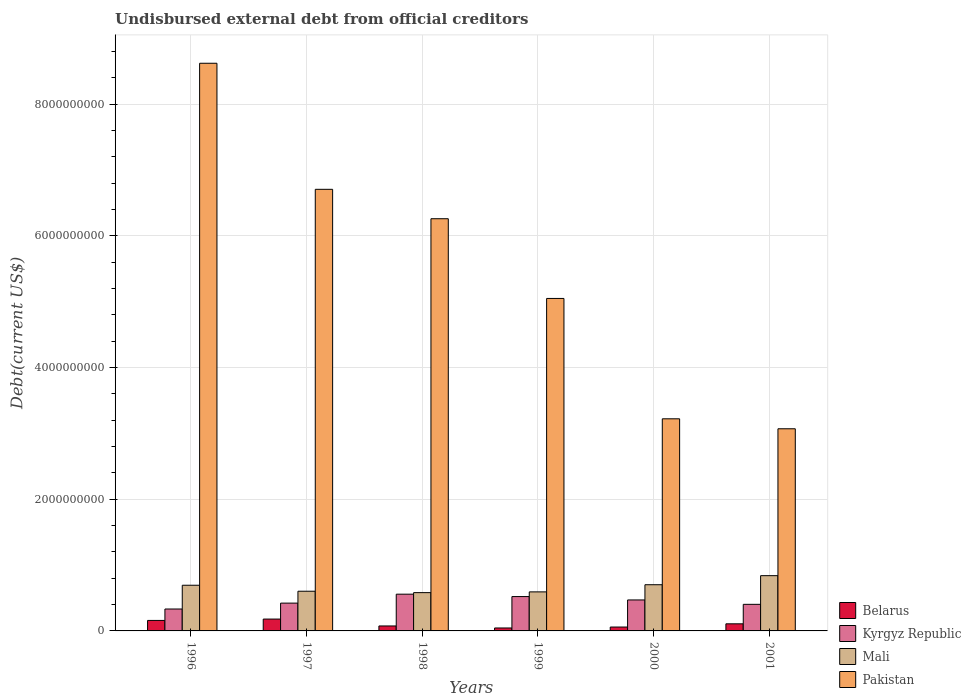How many different coloured bars are there?
Ensure brevity in your answer.  4. How many groups of bars are there?
Offer a terse response. 6. Are the number of bars on each tick of the X-axis equal?
Offer a very short reply. Yes. What is the total debt in Mali in 1996?
Make the answer very short. 6.94e+08. Across all years, what is the maximum total debt in Kyrgyz Republic?
Give a very brief answer. 5.58e+08. Across all years, what is the minimum total debt in Mali?
Your response must be concise. 5.82e+08. In which year was the total debt in Kyrgyz Republic maximum?
Give a very brief answer. 1998. In which year was the total debt in Pakistan minimum?
Offer a very short reply. 2001. What is the total total debt in Belarus in the graph?
Give a very brief answer. 6.27e+08. What is the difference between the total debt in Kyrgyz Republic in 1996 and that in 1999?
Keep it short and to the point. -1.89e+08. What is the difference between the total debt in Kyrgyz Republic in 2000 and the total debt in Mali in 1997?
Provide a succinct answer. -1.33e+08. What is the average total debt in Belarus per year?
Offer a terse response. 1.04e+08. In the year 1996, what is the difference between the total debt in Pakistan and total debt in Belarus?
Your answer should be compact. 8.46e+09. What is the ratio of the total debt in Belarus in 1998 to that in 2000?
Provide a short and direct response. 1.28. Is the difference between the total debt in Pakistan in 1999 and 2001 greater than the difference between the total debt in Belarus in 1999 and 2001?
Your response must be concise. Yes. What is the difference between the highest and the second highest total debt in Kyrgyz Republic?
Give a very brief answer. 3.62e+07. What is the difference between the highest and the lowest total debt in Pakistan?
Your response must be concise. 5.55e+09. Is the sum of the total debt in Belarus in 1997 and 2001 greater than the maximum total debt in Mali across all years?
Keep it short and to the point. No. Is it the case that in every year, the sum of the total debt in Mali and total debt in Belarus is greater than the sum of total debt in Pakistan and total debt in Kyrgyz Republic?
Your response must be concise. Yes. What does the 1st bar from the left in 2000 represents?
Keep it short and to the point. Belarus. What does the 3rd bar from the right in 2001 represents?
Your answer should be compact. Kyrgyz Republic. Are all the bars in the graph horizontal?
Your response must be concise. No. How many years are there in the graph?
Keep it short and to the point. 6. What is the difference between two consecutive major ticks on the Y-axis?
Keep it short and to the point. 2.00e+09. Does the graph contain grids?
Your answer should be very brief. Yes. Where does the legend appear in the graph?
Provide a short and direct response. Bottom right. How many legend labels are there?
Offer a terse response. 4. How are the legend labels stacked?
Provide a succinct answer. Vertical. What is the title of the graph?
Your answer should be very brief. Undisbursed external debt from official creditors. What is the label or title of the Y-axis?
Give a very brief answer. Debt(current US$). What is the Debt(current US$) of Belarus in 1996?
Your answer should be compact. 1.59e+08. What is the Debt(current US$) in Kyrgyz Republic in 1996?
Provide a succinct answer. 3.33e+08. What is the Debt(current US$) of Mali in 1996?
Your response must be concise. 6.94e+08. What is the Debt(current US$) of Pakistan in 1996?
Give a very brief answer. 8.62e+09. What is the Debt(current US$) in Belarus in 1997?
Provide a short and direct response. 1.80e+08. What is the Debt(current US$) of Kyrgyz Republic in 1997?
Keep it short and to the point. 4.22e+08. What is the Debt(current US$) in Mali in 1997?
Offer a very short reply. 6.03e+08. What is the Debt(current US$) in Pakistan in 1997?
Make the answer very short. 6.71e+09. What is the Debt(current US$) in Belarus in 1998?
Provide a succinct answer. 7.55e+07. What is the Debt(current US$) of Kyrgyz Republic in 1998?
Your response must be concise. 5.58e+08. What is the Debt(current US$) of Mali in 1998?
Provide a short and direct response. 5.82e+08. What is the Debt(current US$) in Pakistan in 1998?
Provide a short and direct response. 6.26e+09. What is the Debt(current US$) of Belarus in 1999?
Provide a succinct answer. 4.48e+07. What is the Debt(current US$) of Kyrgyz Republic in 1999?
Give a very brief answer. 5.22e+08. What is the Debt(current US$) of Mali in 1999?
Your response must be concise. 5.93e+08. What is the Debt(current US$) in Pakistan in 1999?
Offer a very short reply. 5.05e+09. What is the Debt(current US$) of Belarus in 2000?
Keep it short and to the point. 5.90e+07. What is the Debt(current US$) of Kyrgyz Republic in 2000?
Keep it short and to the point. 4.70e+08. What is the Debt(current US$) in Mali in 2000?
Offer a very short reply. 7.02e+08. What is the Debt(current US$) of Pakistan in 2000?
Your answer should be compact. 3.22e+09. What is the Debt(current US$) of Belarus in 2001?
Your response must be concise. 1.08e+08. What is the Debt(current US$) in Kyrgyz Republic in 2001?
Provide a succinct answer. 4.04e+08. What is the Debt(current US$) in Mali in 2001?
Offer a terse response. 8.39e+08. What is the Debt(current US$) in Pakistan in 2001?
Give a very brief answer. 3.07e+09. Across all years, what is the maximum Debt(current US$) in Belarus?
Make the answer very short. 1.80e+08. Across all years, what is the maximum Debt(current US$) in Kyrgyz Republic?
Your answer should be very brief. 5.58e+08. Across all years, what is the maximum Debt(current US$) in Mali?
Provide a short and direct response. 8.39e+08. Across all years, what is the maximum Debt(current US$) of Pakistan?
Keep it short and to the point. 8.62e+09. Across all years, what is the minimum Debt(current US$) of Belarus?
Your answer should be very brief. 4.48e+07. Across all years, what is the minimum Debt(current US$) of Kyrgyz Republic?
Offer a terse response. 3.33e+08. Across all years, what is the minimum Debt(current US$) of Mali?
Keep it short and to the point. 5.82e+08. Across all years, what is the minimum Debt(current US$) in Pakistan?
Give a very brief answer. 3.07e+09. What is the total Debt(current US$) of Belarus in the graph?
Provide a short and direct response. 6.27e+08. What is the total Debt(current US$) of Kyrgyz Republic in the graph?
Provide a succinct answer. 2.71e+09. What is the total Debt(current US$) in Mali in the graph?
Provide a succinct answer. 4.01e+09. What is the total Debt(current US$) in Pakistan in the graph?
Your answer should be very brief. 3.29e+1. What is the difference between the Debt(current US$) of Belarus in 1996 and that in 1997?
Offer a terse response. -2.06e+07. What is the difference between the Debt(current US$) of Kyrgyz Republic in 1996 and that in 1997?
Provide a succinct answer. -8.95e+07. What is the difference between the Debt(current US$) in Mali in 1996 and that in 1997?
Ensure brevity in your answer.  9.09e+07. What is the difference between the Debt(current US$) of Pakistan in 1996 and that in 1997?
Your response must be concise. 1.91e+09. What is the difference between the Debt(current US$) in Belarus in 1996 and that in 1998?
Ensure brevity in your answer.  8.40e+07. What is the difference between the Debt(current US$) in Kyrgyz Republic in 1996 and that in 1998?
Your answer should be compact. -2.25e+08. What is the difference between the Debt(current US$) of Mali in 1996 and that in 1998?
Give a very brief answer. 1.12e+08. What is the difference between the Debt(current US$) of Pakistan in 1996 and that in 1998?
Give a very brief answer. 2.36e+09. What is the difference between the Debt(current US$) in Belarus in 1996 and that in 1999?
Offer a very short reply. 1.15e+08. What is the difference between the Debt(current US$) of Kyrgyz Republic in 1996 and that in 1999?
Give a very brief answer. -1.89e+08. What is the difference between the Debt(current US$) of Mali in 1996 and that in 1999?
Offer a terse response. 1.01e+08. What is the difference between the Debt(current US$) in Pakistan in 1996 and that in 1999?
Ensure brevity in your answer.  3.57e+09. What is the difference between the Debt(current US$) in Belarus in 1996 and that in 2000?
Your answer should be compact. 1.00e+08. What is the difference between the Debt(current US$) in Kyrgyz Republic in 1996 and that in 2000?
Your answer should be compact. -1.38e+08. What is the difference between the Debt(current US$) of Mali in 1996 and that in 2000?
Provide a short and direct response. -7.92e+06. What is the difference between the Debt(current US$) in Pakistan in 1996 and that in 2000?
Provide a succinct answer. 5.40e+09. What is the difference between the Debt(current US$) of Belarus in 1996 and that in 2001?
Keep it short and to the point. 5.16e+07. What is the difference between the Debt(current US$) in Kyrgyz Republic in 1996 and that in 2001?
Provide a succinct answer. -7.09e+07. What is the difference between the Debt(current US$) of Mali in 1996 and that in 2001?
Your answer should be compact. -1.45e+08. What is the difference between the Debt(current US$) in Pakistan in 1996 and that in 2001?
Keep it short and to the point. 5.55e+09. What is the difference between the Debt(current US$) in Belarus in 1997 and that in 1998?
Ensure brevity in your answer.  1.05e+08. What is the difference between the Debt(current US$) in Kyrgyz Republic in 1997 and that in 1998?
Your answer should be very brief. -1.36e+08. What is the difference between the Debt(current US$) in Mali in 1997 and that in 1998?
Your answer should be compact. 2.14e+07. What is the difference between the Debt(current US$) in Pakistan in 1997 and that in 1998?
Give a very brief answer. 4.47e+08. What is the difference between the Debt(current US$) of Belarus in 1997 and that in 1999?
Your response must be concise. 1.35e+08. What is the difference between the Debt(current US$) of Kyrgyz Republic in 1997 and that in 1999?
Give a very brief answer. -9.94e+07. What is the difference between the Debt(current US$) in Mali in 1997 and that in 1999?
Offer a terse response. 1.00e+07. What is the difference between the Debt(current US$) in Pakistan in 1997 and that in 1999?
Provide a short and direct response. 1.66e+09. What is the difference between the Debt(current US$) of Belarus in 1997 and that in 2000?
Make the answer very short. 1.21e+08. What is the difference between the Debt(current US$) in Kyrgyz Republic in 1997 and that in 2000?
Your response must be concise. -4.80e+07. What is the difference between the Debt(current US$) in Mali in 1997 and that in 2000?
Provide a succinct answer. -9.88e+07. What is the difference between the Debt(current US$) in Pakistan in 1997 and that in 2000?
Give a very brief answer. 3.49e+09. What is the difference between the Debt(current US$) of Belarus in 1997 and that in 2001?
Make the answer very short. 7.22e+07. What is the difference between the Debt(current US$) of Kyrgyz Republic in 1997 and that in 2001?
Offer a very short reply. 1.86e+07. What is the difference between the Debt(current US$) in Mali in 1997 and that in 2001?
Keep it short and to the point. -2.36e+08. What is the difference between the Debt(current US$) in Pakistan in 1997 and that in 2001?
Make the answer very short. 3.64e+09. What is the difference between the Debt(current US$) of Belarus in 1998 and that in 1999?
Keep it short and to the point. 3.07e+07. What is the difference between the Debt(current US$) in Kyrgyz Republic in 1998 and that in 1999?
Make the answer very short. 3.62e+07. What is the difference between the Debt(current US$) in Mali in 1998 and that in 1999?
Your answer should be compact. -1.13e+07. What is the difference between the Debt(current US$) of Pakistan in 1998 and that in 1999?
Offer a terse response. 1.21e+09. What is the difference between the Debt(current US$) in Belarus in 1998 and that in 2000?
Your answer should be very brief. 1.64e+07. What is the difference between the Debt(current US$) of Kyrgyz Republic in 1998 and that in 2000?
Offer a very short reply. 8.76e+07. What is the difference between the Debt(current US$) of Mali in 1998 and that in 2000?
Offer a very short reply. -1.20e+08. What is the difference between the Debt(current US$) in Pakistan in 1998 and that in 2000?
Provide a short and direct response. 3.04e+09. What is the difference between the Debt(current US$) of Belarus in 1998 and that in 2001?
Keep it short and to the point. -3.24e+07. What is the difference between the Debt(current US$) in Kyrgyz Republic in 1998 and that in 2001?
Offer a terse response. 1.54e+08. What is the difference between the Debt(current US$) of Mali in 1998 and that in 2001?
Your response must be concise. -2.58e+08. What is the difference between the Debt(current US$) in Pakistan in 1998 and that in 2001?
Your answer should be compact. 3.19e+09. What is the difference between the Debt(current US$) in Belarus in 1999 and that in 2000?
Ensure brevity in your answer.  -1.43e+07. What is the difference between the Debt(current US$) in Kyrgyz Republic in 1999 and that in 2000?
Give a very brief answer. 5.14e+07. What is the difference between the Debt(current US$) of Mali in 1999 and that in 2000?
Provide a short and direct response. -1.09e+08. What is the difference between the Debt(current US$) of Pakistan in 1999 and that in 2000?
Ensure brevity in your answer.  1.83e+09. What is the difference between the Debt(current US$) in Belarus in 1999 and that in 2001?
Make the answer very short. -6.31e+07. What is the difference between the Debt(current US$) of Kyrgyz Republic in 1999 and that in 2001?
Your answer should be compact. 1.18e+08. What is the difference between the Debt(current US$) in Mali in 1999 and that in 2001?
Your answer should be very brief. -2.46e+08. What is the difference between the Debt(current US$) of Pakistan in 1999 and that in 2001?
Ensure brevity in your answer.  1.98e+09. What is the difference between the Debt(current US$) of Belarus in 2000 and that in 2001?
Provide a succinct answer. -4.88e+07. What is the difference between the Debt(current US$) in Kyrgyz Republic in 2000 and that in 2001?
Provide a short and direct response. 6.66e+07. What is the difference between the Debt(current US$) in Mali in 2000 and that in 2001?
Keep it short and to the point. -1.38e+08. What is the difference between the Debt(current US$) of Pakistan in 2000 and that in 2001?
Your answer should be very brief. 1.51e+08. What is the difference between the Debt(current US$) of Belarus in 1996 and the Debt(current US$) of Kyrgyz Republic in 1997?
Provide a succinct answer. -2.63e+08. What is the difference between the Debt(current US$) of Belarus in 1996 and the Debt(current US$) of Mali in 1997?
Provide a succinct answer. -4.44e+08. What is the difference between the Debt(current US$) of Belarus in 1996 and the Debt(current US$) of Pakistan in 1997?
Make the answer very short. -6.55e+09. What is the difference between the Debt(current US$) of Kyrgyz Republic in 1996 and the Debt(current US$) of Mali in 1997?
Keep it short and to the point. -2.70e+08. What is the difference between the Debt(current US$) of Kyrgyz Republic in 1996 and the Debt(current US$) of Pakistan in 1997?
Ensure brevity in your answer.  -6.38e+09. What is the difference between the Debt(current US$) of Mali in 1996 and the Debt(current US$) of Pakistan in 1997?
Offer a terse response. -6.01e+09. What is the difference between the Debt(current US$) of Belarus in 1996 and the Debt(current US$) of Kyrgyz Republic in 1998?
Offer a terse response. -3.99e+08. What is the difference between the Debt(current US$) of Belarus in 1996 and the Debt(current US$) of Mali in 1998?
Provide a short and direct response. -4.22e+08. What is the difference between the Debt(current US$) of Belarus in 1996 and the Debt(current US$) of Pakistan in 1998?
Offer a terse response. -6.10e+09. What is the difference between the Debt(current US$) of Kyrgyz Republic in 1996 and the Debt(current US$) of Mali in 1998?
Your answer should be compact. -2.49e+08. What is the difference between the Debt(current US$) of Kyrgyz Republic in 1996 and the Debt(current US$) of Pakistan in 1998?
Offer a terse response. -5.93e+09. What is the difference between the Debt(current US$) of Mali in 1996 and the Debt(current US$) of Pakistan in 1998?
Keep it short and to the point. -5.57e+09. What is the difference between the Debt(current US$) in Belarus in 1996 and the Debt(current US$) in Kyrgyz Republic in 1999?
Provide a succinct answer. -3.62e+08. What is the difference between the Debt(current US$) in Belarus in 1996 and the Debt(current US$) in Mali in 1999?
Keep it short and to the point. -4.34e+08. What is the difference between the Debt(current US$) of Belarus in 1996 and the Debt(current US$) of Pakistan in 1999?
Provide a short and direct response. -4.89e+09. What is the difference between the Debt(current US$) of Kyrgyz Republic in 1996 and the Debt(current US$) of Mali in 1999?
Ensure brevity in your answer.  -2.60e+08. What is the difference between the Debt(current US$) in Kyrgyz Republic in 1996 and the Debt(current US$) in Pakistan in 1999?
Offer a very short reply. -4.72e+09. What is the difference between the Debt(current US$) in Mali in 1996 and the Debt(current US$) in Pakistan in 1999?
Your response must be concise. -4.36e+09. What is the difference between the Debt(current US$) in Belarus in 1996 and the Debt(current US$) in Kyrgyz Republic in 2000?
Give a very brief answer. -3.11e+08. What is the difference between the Debt(current US$) in Belarus in 1996 and the Debt(current US$) in Mali in 2000?
Provide a succinct answer. -5.42e+08. What is the difference between the Debt(current US$) in Belarus in 1996 and the Debt(current US$) in Pakistan in 2000?
Offer a terse response. -3.06e+09. What is the difference between the Debt(current US$) in Kyrgyz Republic in 1996 and the Debt(current US$) in Mali in 2000?
Ensure brevity in your answer.  -3.69e+08. What is the difference between the Debt(current US$) of Kyrgyz Republic in 1996 and the Debt(current US$) of Pakistan in 2000?
Your answer should be very brief. -2.89e+09. What is the difference between the Debt(current US$) of Mali in 1996 and the Debt(current US$) of Pakistan in 2000?
Your response must be concise. -2.53e+09. What is the difference between the Debt(current US$) in Belarus in 1996 and the Debt(current US$) in Kyrgyz Republic in 2001?
Offer a very short reply. -2.44e+08. What is the difference between the Debt(current US$) in Belarus in 1996 and the Debt(current US$) in Mali in 2001?
Give a very brief answer. -6.80e+08. What is the difference between the Debt(current US$) of Belarus in 1996 and the Debt(current US$) of Pakistan in 2001?
Your response must be concise. -2.91e+09. What is the difference between the Debt(current US$) in Kyrgyz Republic in 1996 and the Debt(current US$) in Mali in 2001?
Provide a short and direct response. -5.06e+08. What is the difference between the Debt(current US$) in Kyrgyz Republic in 1996 and the Debt(current US$) in Pakistan in 2001?
Offer a terse response. -2.74e+09. What is the difference between the Debt(current US$) of Mali in 1996 and the Debt(current US$) of Pakistan in 2001?
Your response must be concise. -2.38e+09. What is the difference between the Debt(current US$) of Belarus in 1997 and the Debt(current US$) of Kyrgyz Republic in 1998?
Offer a very short reply. -3.78e+08. What is the difference between the Debt(current US$) in Belarus in 1997 and the Debt(current US$) in Mali in 1998?
Ensure brevity in your answer.  -4.02e+08. What is the difference between the Debt(current US$) in Belarus in 1997 and the Debt(current US$) in Pakistan in 1998?
Provide a succinct answer. -6.08e+09. What is the difference between the Debt(current US$) of Kyrgyz Republic in 1997 and the Debt(current US$) of Mali in 1998?
Ensure brevity in your answer.  -1.59e+08. What is the difference between the Debt(current US$) of Kyrgyz Republic in 1997 and the Debt(current US$) of Pakistan in 1998?
Give a very brief answer. -5.84e+09. What is the difference between the Debt(current US$) in Mali in 1997 and the Debt(current US$) in Pakistan in 1998?
Your response must be concise. -5.66e+09. What is the difference between the Debt(current US$) in Belarus in 1997 and the Debt(current US$) in Kyrgyz Republic in 1999?
Keep it short and to the point. -3.42e+08. What is the difference between the Debt(current US$) of Belarus in 1997 and the Debt(current US$) of Mali in 1999?
Offer a terse response. -4.13e+08. What is the difference between the Debt(current US$) of Belarus in 1997 and the Debt(current US$) of Pakistan in 1999?
Your answer should be compact. -4.87e+09. What is the difference between the Debt(current US$) in Kyrgyz Republic in 1997 and the Debt(current US$) in Mali in 1999?
Provide a succinct answer. -1.71e+08. What is the difference between the Debt(current US$) of Kyrgyz Republic in 1997 and the Debt(current US$) of Pakistan in 1999?
Your response must be concise. -4.63e+09. What is the difference between the Debt(current US$) in Mali in 1997 and the Debt(current US$) in Pakistan in 1999?
Provide a succinct answer. -4.45e+09. What is the difference between the Debt(current US$) of Belarus in 1997 and the Debt(current US$) of Kyrgyz Republic in 2000?
Make the answer very short. -2.90e+08. What is the difference between the Debt(current US$) of Belarus in 1997 and the Debt(current US$) of Mali in 2000?
Offer a very short reply. -5.22e+08. What is the difference between the Debt(current US$) in Belarus in 1997 and the Debt(current US$) in Pakistan in 2000?
Offer a very short reply. -3.04e+09. What is the difference between the Debt(current US$) in Kyrgyz Republic in 1997 and the Debt(current US$) in Mali in 2000?
Ensure brevity in your answer.  -2.79e+08. What is the difference between the Debt(current US$) in Kyrgyz Republic in 1997 and the Debt(current US$) in Pakistan in 2000?
Your answer should be very brief. -2.80e+09. What is the difference between the Debt(current US$) of Mali in 1997 and the Debt(current US$) of Pakistan in 2000?
Your answer should be compact. -2.62e+09. What is the difference between the Debt(current US$) of Belarus in 1997 and the Debt(current US$) of Kyrgyz Republic in 2001?
Your answer should be compact. -2.24e+08. What is the difference between the Debt(current US$) in Belarus in 1997 and the Debt(current US$) in Mali in 2001?
Your response must be concise. -6.59e+08. What is the difference between the Debt(current US$) of Belarus in 1997 and the Debt(current US$) of Pakistan in 2001?
Your answer should be compact. -2.89e+09. What is the difference between the Debt(current US$) in Kyrgyz Republic in 1997 and the Debt(current US$) in Mali in 2001?
Your answer should be compact. -4.17e+08. What is the difference between the Debt(current US$) in Kyrgyz Republic in 1997 and the Debt(current US$) in Pakistan in 2001?
Your answer should be compact. -2.65e+09. What is the difference between the Debt(current US$) in Mali in 1997 and the Debt(current US$) in Pakistan in 2001?
Ensure brevity in your answer.  -2.47e+09. What is the difference between the Debt(current US$) in Belarus in 1998 and the Debt(current US$) in Kyrgyz Republic in 1999?
Ensure brevity in your answer.  -4.46e+08. What is the difference between the Debt(current US$) in Belarus in 1998 and the Debt(current US$) in Mali in 1999?
Your answer should be very brief. -5.18e+08. What is the difference between the Debt(current US$) of Belarus in 1998 and the Debt(current US$) of Pakistan in 1999?
Ensure brevity in your answer.  -4.98e+09. What is the difference between the Debt(current US$) in Kyrgyz Republic in 1998 and the Debt(current US$) in Mali in 1999?
Your response must be concise. -3.49e+07. What is the difference between the Debt(current US$) of Kyrgyz Republic in 1998 and the Debt(current US$) of Pakistan in 1999?
Make the answer very short. -4.49e+09. What is the difference between the Debt(current US$) in Mali in 1998 and the Debt(current US$) in Pakistan in 1999?
Your answer should be compact. -4.47e+09. What is the difference between the Debt(current US$) in Belarus in 1998 and the Debt(current US$) in Kyrgyz Republic in 2000?
Provide a succinct answer. -3.95e+08. What is the difference between the Debt(current US$) of Belarus in 1998 and the Debt(current US$) of Mali in 2000?
Provide a short and direct response. -6.26e+08. What is the difference between the Debt(current US$) of Belarus in 1998 and the Debt(current US$) of Pakistan in 2000?
Your answer should be very brief. -3.15e+09. What is the difference between the Debt(current US$) of Kyrgyz Republic in 1998 and the Debt(current US$) of Mali in 2000?
Keep it short and to the point. -1.44e+08. What is the difference between the Debt(current US$) in Kyrgyz Republic in 1998 and the Debt(current US$) in Pakistan in 2000?
Your answer should be compact. -2.66e+09. What is the difference between the Debt(current US$) of Mali in 1998 and the Debt(current US$) of Pakistan in 2000?
Provide a succinct answer. -2.64e+09. What is the difference between the Debt(current US$) in Belarus in 1998 and the Debt(current US$) in Kyrgyz Republic in 2001?
Offer a very short reply. -3.28e+08. What is the difference between the Debt(current US$) in Belarus in 1998 and the Debt(current US$) in Mali in 2001?
Your response must be concise. -7.64e+08. What is the difference between the Debt(current US$) in Belarus in 1998 and the Debt(current US$) in Pakistan in 2001?
Give a very brief answer. -3.00e+09. What is the difference between the Debt(current US$) in Kyrgyz Republic in 1998 and the Debt(current US$) in Mali in 2001?
Give a very brief answer. -2.81e+08. What is the difference between the Debt(current US$) of Kyrgyz Republic in 1998 and the Debt(current US$) of Pakistan in 2001?
Offer a very short reply. -2.51e+09. What is the difference between the Debt(current US$) in Mali in 1998 and the Debt(current US$) in Pakistan in 2001?
Make the answer very short. -2.49e+09. What is the difference between the Debt(current US$) of Belarus in 1999 and the Debt(current US$) of Kyrgyz Republic in 2000?
Ensure brevity in your answer.  -4.26e+08. What is the difference between the Debt(current US$) in Belarus in 1999 and the Debt(current US$) in Mali in 2000?
Give a very brief answer. -6.57e+08. What is the difference between the Debt(current US$) of Belarus in 1999 and the Debt(current US$) of Pakistan in 2000?
Your response must be concise. -3.18e+09. What is the difference between the Debt(current US$) of Kyrgyz Republic in 1999 and the Debt(current US$) of Mali in 2000?
Your response must be concise. -1.80e+08. What is the difference between the Debt(current US$) of Kyrgyz Republic in 1999 and the Debt(current US$) of Pakistan in 2000?
Make the answer very short. -2.70e+09. What is the difference between the Debt(current US$) of Mali in 1999 and the Debt(current US$) of Pakistan in 2000?
Your answer should be very brief. -2.63e+09. What is the difference between the Debt(current US$) in Belarus in 1999 and the Debt(current US$) in Kyrgyz Republic in 2001?
Keep it short and to the point. -3.59e+08. What is the difference between the Debt(current US$) in Belarus in 1999 and the Debt(current US$) in Mali in 2001?
Provide a succinct answer. -7.95e+08. What is the difference between the Debt(current US$) of Belarus in 1999 and the Debt(current US$) of Pakistan in 2001?
Your answer should be very brief. -3.03e+09. What is the difference between the Debt(current US$) of Kyrgyz Republic in 1999 and the Debt(current US$) of Mali in 2001?
Give a very brief answer. -3.17e+08. What is the difference between the Debt(current US$) of Kyrgyz Republic in 1999 and the Debt(current US$) of Pakistan in 2001?
Make the answer very short. -2.55e+09. What is the difference between the Debt(current US$) in Mali in 1999 and the Debt(current US$) in Pakistan in 2001?
Your answer should be very brief. -2.48e+09. What is the difference between the Debt(current US$) in Belarus in 2000 and the Debt(current US$) in Kyrgyz Republic in 2001?
Make the answer very short. -3.45e+08. What is the difference between the Debt(current US$) of Belarus in 2000 and the Debt(current US$) of Mali in 2001?
Your answer should be compact. -7.80e+08. What is the difference between the Debt(current US$) of Belarus in 2000 and the Debt(current US$) of Pakistan in 2001?
Your answer should be compact. -3.01e+09. What is the difference between the Debt(current US$) in Kyrgyz Republic in 2000 and the Debt(current US$) in Mali in 2001?
Offer a terse response. -3.69e+08. What is the difference between the Debt(current US$) in Kyrgyz Republic in 2000 and the Debt(current US$) in Pakistan in 2001?
Your answer should be compact. -2.60e+09. What is the difference between the Debt(current US$) of Mali in 2000 and the Debt(current US$) of Pakistan in 2001?
Keep it short and to the point. -2.37e+09. What is the average Debt(current US$) in Belarus per year?
Give a very brief answer. 1.04e+08. What is the average Debt(current US$) of Kyrgyz Republic per year?
Keep it short and to the point. 4.52e+08. What is the average Debt(current US$) of Mali per year?
Your response must be concise. 6.69e+08. What is the average Debt(current US$) in Pakistan per year?
Ensure brevity in your answer.  5.49e+09. In the year 1996, what is the difference between the Debt(current US$) in Belarus and Debt(current US$) in Kyrgyz Republic?
Offer a very short reply. -1.73e+08. In the year 1996, what is the difference between the Debt(current US$) of Belarus and Debt(current US$) of Mali?
Your answer should be very brief. -5.34e+08. In the year 1996, what is the difference between the Debt(current US$) in Belarus and Debt(current US$) in Pakistan?
Provide a short and direct response. -8.46e+09. In the year 1996, what is the difference between the Debt(current US$) of Kyrgyz Republic and Debt(current US$) of Mali?
Ensure brevity in your answer.  -3.61e+08. In the year 1996, what is the difference between the Debt(current US$) of Kyrgyz Republic and Debt(current US$) of Pakistan?
Keep it short and to the point. -8.29e+09. In the year 1996, what is the difference between the Debt(current US$) in Mali and Debt(current US$) in Pakistan?
Your answer should be compact. -7.93e+09. In the year 1997, what is the difference between the Debt(current US$) of Belarus and Debt(current US$) of Kyrgyz Republic?
Provide a short and direct response. -2.42e+08. In the year 1997, what is the difference between the Debt(current US$) in Belarus and Debt(current US$) in Mali?
Your response must be concise. -4.23e+08. In the year 1997, what is the difference between the Debt(current US$) of Belarus and Debt(current US$) of Pakistan?
Your answer should be very brief. -6.53e+09. In the year 1997, what is the difference between the Debt(current US$) of Kyrgyz Republic and Debt(current US$) of Mali?
Your answer should be compact. -1.81e+08. In the year 1997, what is the difference between the Debt(current US$) in Kyrgyz Republic and Debt(current US$) in Pakistan?
Your answer should be very brief. -6.29e+09. In the year 1997, what is the difference between the Debt(current US$) of Mali and Debt(current US$) of Pakistan?
Provide a succinct answer. -6.11e+09. In the year 1998, what is the difference between the Debt(current US$) of Belarus and Debt(current US$) of Kyrgyz Republic?
Offer a very short reply. -4.83e+08. In the year 1998, what is the difference between the Debt(current US$) in Belarus and Debt(current US$) in Mali?
Your answer should be compact. -5.06e+08. In the year 1998, what is the difference between the Debt(current US$) in Belarus and Debt(current US$) in Pakistan?
Your answer should be compact. -6.19e+09. In the year 1998, what is the difference between the Debt(current US$) of Kyrgyz Republic and Debt(current US$) of Mali?
Make the answer very short. -2.35e+07. In the year 1998, what is the difference between the Debt(current US$) of Kyrgyz Republic and Debt(current US$) of Pakistan?
Ensure brevity in your answer.  -5.70e+09. In the year 1998, what is the difference between the Debt(current US$) in Mali and Debt(current US$) in Pakistan?
Provide a short and direct response. -5.68e+09. In the year 1999, what is the difference between the Debt(current US$) of Belarus and Debt(current US$) of Kyrgyz Republic?
Offer a terse response. -4.77e+08. In the year 1999, what is the difference between the Debt(current US$) in Belarus and Debt(current US$) in Mali?
Your response must be concise. -5.48e+08. In the year 1999, what is the difference between the Debt(current US$) of Belarus and Debt(current US$) of Pakistan?
Give a very brief answer. -5.01e+09. In the year 1999, what is the difference between the Debt(current US$) in Kyrgyz Republic and Debt(current US$) in Mali?
Provide a succinct answer. -7.11e+07. In the year 1999, what is the difference between the Debt(current US$) of Kyrgyz Republic and Debt(current US$) of Pakistan?
Your answer should be compact. -4.53e+09. In the year 1999, what is the difference between the Debt(current US$) in Mali and Debt(current US$) in Pakistan?
Offer a very short reply. -4.46e+09. In the year 2000, what is the difference between the Debt(current US$) in Belarus and Debt(current US$) in Kyrgyz Republic?
Keep it short and to the point. -4.11e+08. In the year 2000, what is the difference between the Debt(current US$) of Belarus and Debt(current US$) of Mali?
Keep it short and to the point. -6.43e+08. In the year 2000, what is the difference between the Debt(current US$) of Belarus and Debt(current US$) of Pakistan?
Ensure brevity in your answer.  -3.16e+09. In the year 2000, what is the difference between the Debt(current US$) in Kyrgyz Republic and Debt(current US$) in Mali?
Your answer should be very brief. -2.31e+08. In the year 2000, what is the difference between the Debt(current US$) of Kyrgyz Republic and Debt(current US$) of Pakistan?
Your answer should be very brief. -2.75e+09. In the year 2000, what is the difference between the Debt(current US$) in Mali and Debt(current US$) in Pakistan?
Offer a very short reply. -2.52e+09. In the year 2001, what is the difference between the Debt(current US$) of Belarus and Debt(current US$) of Kyrgyz Republic?
Make the answer very short. -2.96e+08. In the year 2001, what is the difference between the Debt(current US$) of Belarus and Debt(current US$) of Mali?
Keep it short and to the point. -7.31e+08. In the year 2001, what is the difference between the Debt(current US$) of Belarus and Debt(current US$) of Pakistan?
Your answer should be very brief. -2.96e+09. In the year 2001, what is the difference between the Debt(current US$) in Kyrgyz Republic and Debt(current US$) in Mali?
Keep it short and to the point. -4.35e+08. In the year 2001, what is the difference between the Debt(current US$) of Kyrgyz Republic and Debt(current US$) of Pakistan?
Make the answer very short. -2.67e+09. In the year 2001, what is the difference between the Debt(current US$) of Mali and Debt(current US$) of Pakistan?
Your answer should be compact. -2.23e+09. What is the ratio of the Debt(current US$) of Belarus in 1996 to that in 1997?
Offer a terse response. 0.89. What is the ratio of the Debt(current US$) of Kyrgyz Republic in 1996 to that in 1997?
Your answer should be very brief. 0.79. What is the ratio of the Debt(current US$) in Mali in 1996 to that in 1997?
Provide a succinct answer. 1.15. What is the ratio of the Debt(current US$) of Pakistan in 1996 to that in 1997?
Provide a succinct answer. 1.29. What is the ratio of the Debt(current US$) in Belarus in 1996 to that in 1998?
Give a very brief answer. 2.11. What is the ratio of the Debt(current US$) of Kyrgyz Republic in 1996 to that in 1998?
Your response must be concise. 0.6. What is the ratio of the Debt(current US$) in Mali in 1996 to that in 1998?
Your answer should be very brief. 1.19. What is the ratio of the Debt(current US$) in Pakistan in 1996 to that in 1998?
Offer a very short reply. 1.38. What is the ratio of the Debt(current US$) in Belarus in 1996 to that in 1999?
Make the answer very short. 3.56. What is the ratio of the Debt(current US$) of Kyrgyz Republic in 1996 to that in 1999?
Make the answer very short. 0.64. What is the ratio of the Debt(current US$) in Mali in 1996 to that in 1999?
Keep it short and to the point. 1.17. What is the ratio of the Debt(current US$) in Pakistan in 1996 to that in 1999?
Keep it short and to the point. 1.71. What is the ratio of the Debt(current US$) of Belarus in 1996 to that in 2000?
Make the answer very short. 2.7. What is the ratio of the Debt(current US$) in Kyrgyz Republic in 1996 to that in 2000?
Provide a succinct answer. 0.71. What is the ratio of the Debt(current US$) in Mali in 1996 to that in 2000?
Your answer should be compact. 0.99. What is the ratio of the Debt(current US$) of Pakistan in 1996 to that in 2000?
Offer a terse response. 2.68. What is the ratio of the Debt(current US$) of Belarus in 1996 to that in 2001?
Your answer should be very brief. 1.48. What is the ratio of the Debt(current US$) in Kyrgyz Republic in 1996 to that in 2001?
Your response must be concise. 0.82. What is the ratio of the Debt(current US$) in Mali in 1996 to that in 2001?
Provide a succinct answer. 0.83. What is the ratio of the Debt(current US$) of Pakistan in 1996 to that in 2001?
Your answer should be compact. 2.81. What is the ratio of the Debt(current US$) in Belarus in 1997 to that in 1998?
Your answer should be compact. 2.39. What is the ratio of the Debt(current US$) in Kyrgyz Republic in 1997 to that in 1998?
Your answer should be very brief. 0.76. What is the ratio of the Debt(current US$) in Mali in 1997 to that in 1998?
Offer a terse response. 1.04. What is the ratio of the Debt(current US$) of Pakistan in 1997 to that in 1998?
Offer a very short reply. 1.07. What is the ratio of the Debt(current US$) of Belarus in 1997 to that in 1999?
Ensure brevity in your answer.  4.02. What is the ratio of the Debt(current US$) of Kyrgyz Republic in 1997 to that in 1999?
Offer a very short reply. 0.81. What is the ratio of the Debt(current US$) of Mali in 1997 to that in 1999?
Keep it short and to the point. 1.02. What is the ratio of the Debt(current US$) in Pakistan in 1997 to that in 1999?
Provide a succinct answer. 1.33. What is the ratio of the Debt(current US$) of Belarus in 1997 to that in 2000?
Offer a very short reply. 3.05. What is the ratio of the Debt(current US$) in Kyrgyz Republic in 1997 to that in 2000?
Make the answer very short. 0.9. What is the ratio of the Debt(current US$) in Mali in 1997 to that in 2000?
Your answer should be very brief. 0.86. What is the ratio of the Debt(current US$) in Pakistan in 1997 to that in 2000?
Your answer should be compact. 2.08. What is the ratio of the Debt(current US$) in Belarus in 1997 to that in 2001?
Keep it short and to the point. 1.67. What is the ratio of the Debt(current US$) of Kyrgyz Republic in 1997 to that in 2001?
Offer a terse response. 1.05. What is the ratio of the Debt(current US$) in Mali in 1997 to that in 2001?
Make the answer very short. 0.72. What is the ratio of the Debt(current US$) of Pakistan in 1997 to that in 2001?
Offer a very short reply. 2.18. What is the ratio of the Debt(current US$) of Belarus in 1998 to that in 1999?
Provide a short and direct response. 1.69. What is the ratio of the Debt(current US$) of Kyrgyz Republic in 1998 to that in 1999?
Your response must be concise. 1.07. What is the ratio of the Debt(current US$) of Mali in 1998 to that in 1999?
Your response must be concise. 0.98. What is the ratio of the Debt(current US$) in Pakistan in 1998 to that in 1999?
Give a very brief answer. 1.24. What is the ratio of the Debt(current US$) in Belarus in 1998 to that in 2000?
Your response must be concise. 1.28. What is the ratio of the Debt(current US$) in Kyrgyz Republic in 1998 to that in 2000?
Make the answer very short. 1.19. What is the ratio of the Debt(current US$) of Mali in 1998 to that in 2000?
Give a very brief answer. 0.83. What is the ratio of the Debt(current US$) in Pakistan in 1998 to that in 2000?
Offer a very short reply. 1.94. What is the ratio of the Debt(current US$) in Belarus in 1998 to that in 2001?
Your answer should be compact. 0.7. What is the ratio of the Debt(current US$) of Kyrgyz Republic in 1998 to that in 2001?
Give a very brief answer. 1.38. What is the ratio of the Debt(current US$) of Mali in 1998 to that in 2001?
Keep it short and to the point. 0.69. What is the ratio of the Debt(current US$) of Pakistan in 1998 to that in 2001?
Ensure brevity in your answer.  2.04. What is the ratio of the Debt(current US$) of Belarus in 1999 to that in 2000?
Give a very brief answer. 0.76. What is the ratio of the Debt(current US$) in Kyrgyz Republic in 1999 to that in 2000?
Give a very brief answer. 1.11. What is the ratio of the Debt(current US$) in Mali in 1999 to that in 2000?
Keep it short and to the point. 0.84. What is the ratio of the Debt(current US$) in Pakistan in 1999 to that in 2000?
Make the answer very short. 1.57. What is the ratio of the Debt(current US$) of Belarus in 1999 to that in 2001?
Provide a succinct answer. 0.41. What is the ratio of the Debt(current US$) of Kyrgyz Republic in 1999 to that in 2001?
Keep it short and to the point. 1.29. What is the ratio of the Debt(current US$) in Mali in 1999 to that in 2001?
Your answer should be very brief. 0.71. What is the ratio of the Debt(current US$) of Pakistan in 1999 to that in 2001?
Offer a very short reply. 1.64. What is the ratio of the Debt(current US$) of Belarus in 2000 to that in 2001?
Provide a short and direct response. 0.55. What is the ratio of the Debt(current US$) in Kyrgyz Republic in 2000 to that in 2001?
Provide a short and direct response. 1.16. What is the ratio of the Debt(current US$) of Mali in 2000 to that in 2001?
Your response must be concise. 0.84. What is the ratio of the Debt(current US$) in Pakistan in 2000 to that in 2001?
Make the answer very short. 1.05. What is the difference between the highest and the second highest Debt(current US$) of Belarus?
Offer a terse response. 2.06e+07. What is the difference between the highest and the second highest Debt(current US$) in Kyrgyz Republic?
Your response must be concise. 3.62e+07. What is the difference between the highest and the second highest Debt(current US$) of Mali?
Offer a very short reply. 1.38e+08. What is the difference between the highest and the second highest Debt(current US$) in Pakistan?
Offer a terse response. 1.91e+09. What is the difference between the highest and the lowest Debt(current US$) of Belarus?
Offer a terse response. 1.35e+08. What is the difference between the highest and the lowest Debt(current US$) of Kyrgyz Republic?
Your answer should be very brief. 2.25e+08. What is the difference between the highest and the lowest Debt(current US$) in Mali?
Give a very brief answer. 2.58e+08. What is the difference between the highest and the lowest Debt(current US$) of Pakistan?
Offer a terse response. 5.55e+09. 